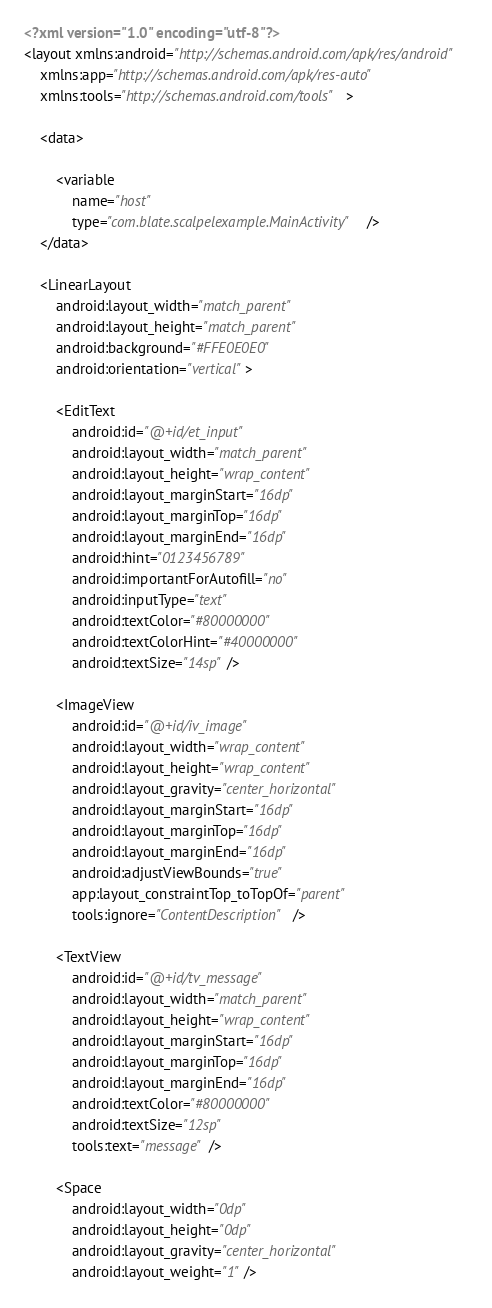Convert code to text. <code><loc_0><loc_0><loc_500><loc_500><_XML_><?xml version="1.0" encoding="utf-8"?>
<layout xmlns:android="http://schemas.android.com/apk/res/android"
    xmlns:app="http://schemas.android.com/apk/res-auto"
    xmlns:tools="http://schemas.android.com/tools">

    <data>

        <variable
            name="host"
            type="com.blate.scalpelexample.MainActivity" />
    </data>

    <LinearLayout
        android:layout_width="match_parent"
        android:layout_height="match_parent"
        android:background="#FFE0E0E0"
        android:orientation="vertical">

        <EditText
            android:id="@+id/et_input"
            android:layout_width="match_parent"
            android:layout_height="wrap_content"
            android:layout_marginStart="16dp"
            android:layout_marginTop="16dp"
            android:layout_marginEnd="16dp"
            android:hint="0123456789"
            android:importantForAutofill="no"
            android:inputType="text"
            android:textColor="#80000000"
            android:textColorHint="#40000000"
            android:textSize="14sp" />

        <ImageView
            android:id="@+id/iv_image"
            android:layout_width="wrap_content"
            android:layout_height="wrap_content"
            android:layout_gravity="center_horizontal"
            android:layout_marginStart="16dp"
            android:layout_marginTop="16dp"
            android:layout_marginEnd="16dp"
            android:adjustViewBounds="true"
            app:layout_constraintTop_toTopOf="parent"
            tools:ignore="ContentDescription" />

        <TextView
            android:id="@+id/tv_message"
            android:layout_width="match_parent"
            android:layout_height="wrap_content"
            android:layout_marginStart="16dp"
            android:layout_marginTop="16dp"
            android:layout_marginEnd="16dp"
            android:textColor="#80000000"
            android:textSize="12sp"
            tools:text="message" />

        <Space
            android:layout_width="0dp"
            android:layout_height="0dp"
            android:layout_gravity="center_horizontal"
            android:layout_weight="1" />
</code> 